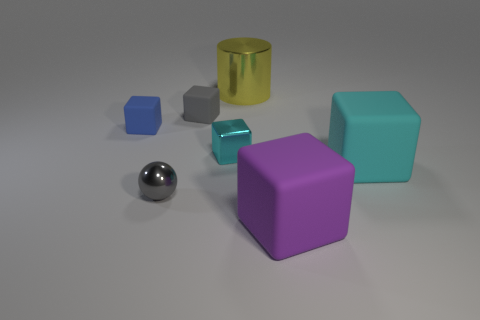Is there a certain symmetry or pattern visible among the objects? While there is no rigid symmetry at play, a sense of balance is achieved by the distribution of shapes and colors, with the central position of the metallic sphere providing a focal point. Which of these objects stands out the most, and why? The metallic sphere stands out due to its reflective surface and spherical shape, contrasting with the matte textures and angular forms of the blocks. Its central placement also draws the eye. 